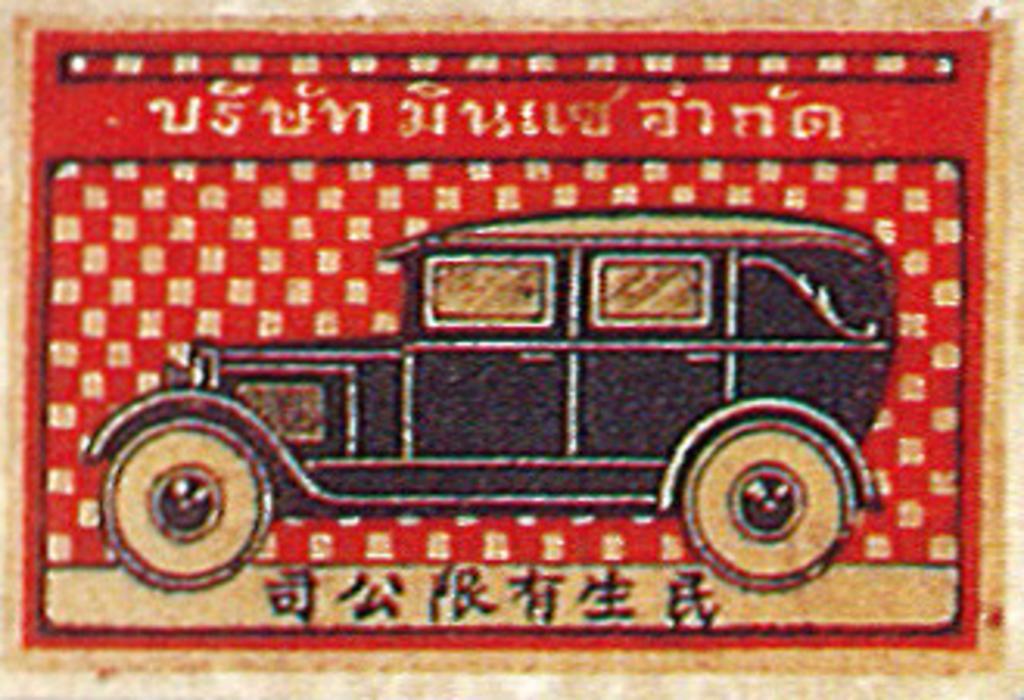Can you describe this image briefly? In this picture, it is looking like a poster of a vehicle and behind the vehicle there is a red an gold background. 